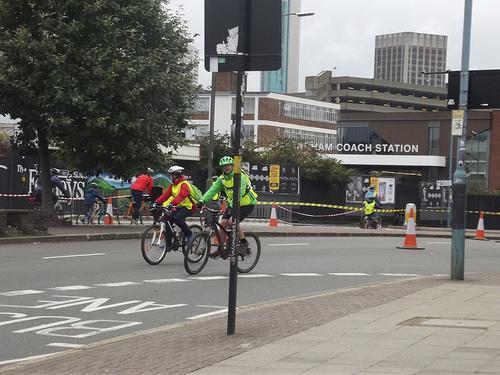How many bikers are on the road?
Give a very brief answer. 2. How many cones are shown?
Give a very brief answer. 5. How many people are wearing a green helmet?
Give a very brief answer. 1. 